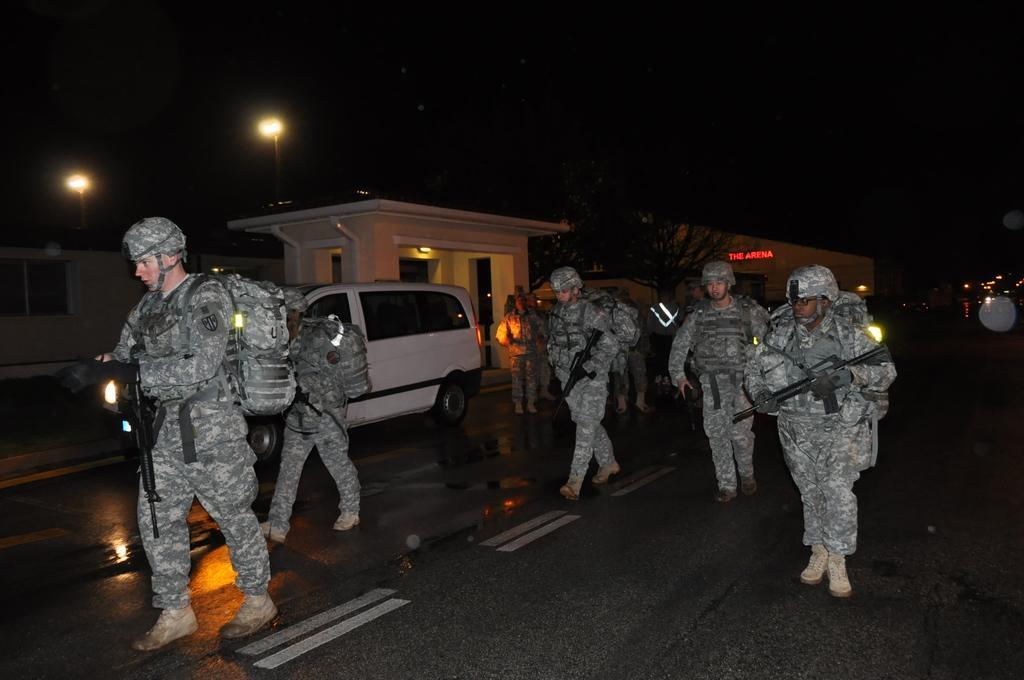How would you summarize this image in a sentence or two? In this image we can see a group of men walking on the road holding the guns. We can also see a car on the road. On the backside we can see some buildings, trees, a signboard, some lights, the street poles and the sky. 